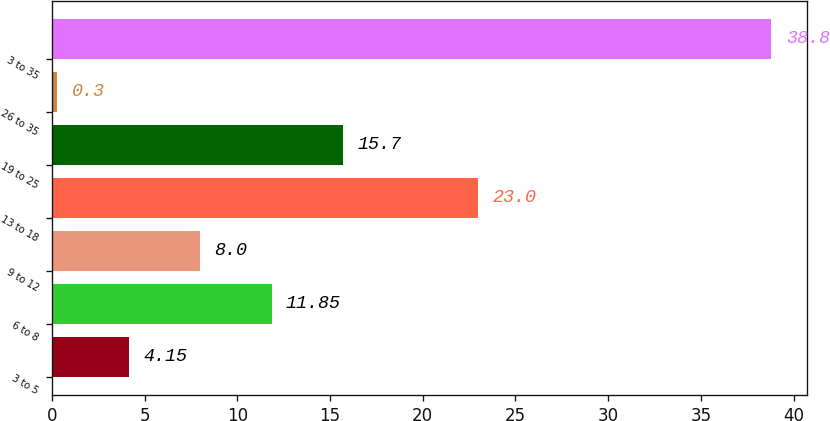Convert chart to OTSL. <chart><loc_0><loc_0><loc_500><loc_500><bar_chart><fcel>3 to 5<fcel>6 to 8<fcel>9 to 12<fcel>13 to 18<fcel>19 to 25<fcel>26 to 35<fcel>3 to 35<nl><fcel>4.15<fcel>11.85<fcel>8<fcel>23<fcel>15.7<fcel>0.3<fcel>38.8<nl></chart> 